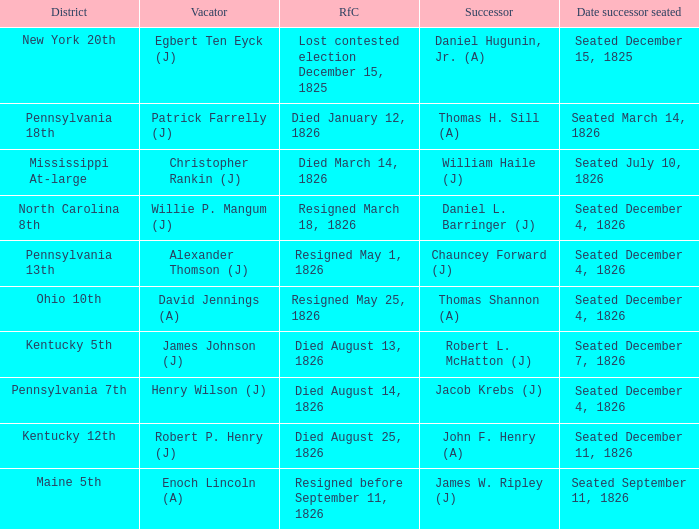Name the vacator for reason for change died january 12, 1826 Patrick Farrelly (J). 